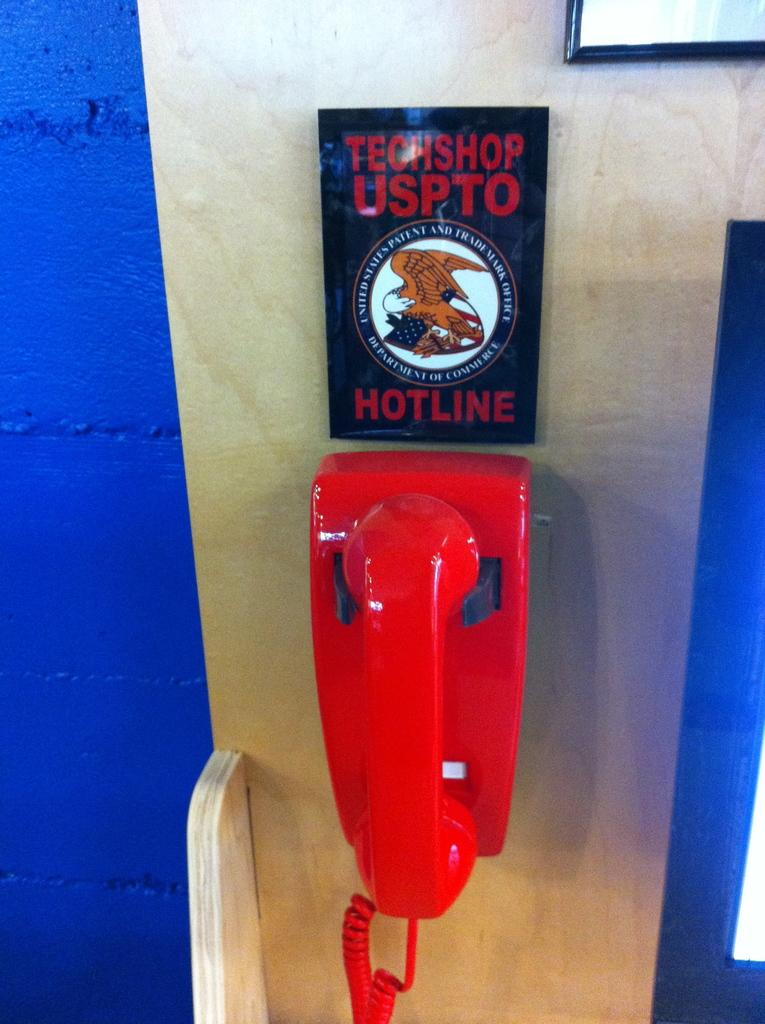<image>
Share a concise interpretation of the image provided. a phone that says hotline on it with an eagle 